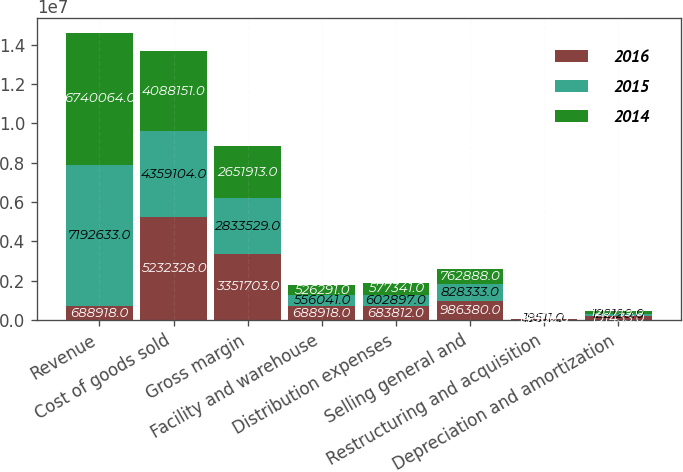<chart> <loc_0><loc_0><loc_500><loc_500><stacked_bar_chart><ecel><fcel>Revenue<fcel>Cost of goods sold<fcel>Gross margin<fcel>Facility and warehouse<fcel>Distribution expenses<fcel>Selling general and<fcel>Restructuring and acquisition<fcel>Depreciation and amortization<nl><fcel>2016<fcel>688918<fcel>5.23233e+06<fcel>3.3517e+06<fcel>688918<fcel>683812<fcel>986380<fcel>37762<fcel>191433<nl><fcel>2015<fcel>7.19263e+06<fcel>4.3591e+06<fcel>2.83353e+06<fcel>556041<fcel>602897<fcel>828333<fcel>19511<fcel>122120<nl><fcel>2014<fcel>6.74006e+06<fcel>4.08815e+06<fcel>2.65191e+06<fcel>526291<fcel>577341<fcel>762888<fcel>14806<fcel>120719<nl></chart> 